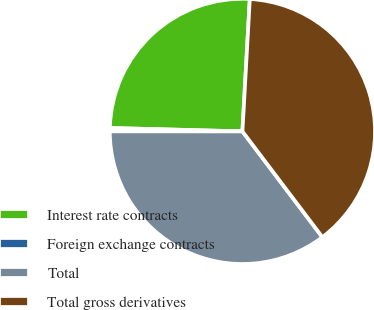<chart> <loc_0><loc_0><loc_500><loc_500><pie_chart><fcel>Interest rate contracts<fcel>Foreign exchange contracts<fcel>Total<fcel>Total gross derivatives<nl><fcel>25.48%<fcel>0.4%<fcel>35.31%<fcel>38.81%<nl></chart> 